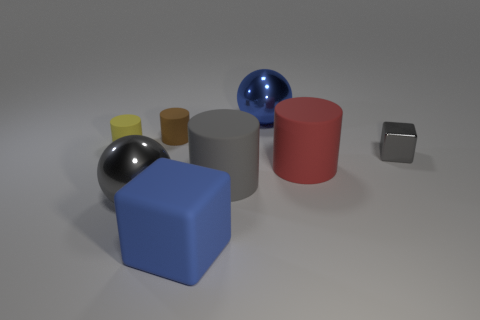Subtract all gray cylinders. How many cylinders are left? 3 Add 1 big gray things. How many objects exist? 9 Subtract all gray balls. How many balls are left? 1 Subtract all spheres. How many objects are left? 6 Subtract all red cylinders. Subtract all red cubes. How many cylinders are left? 3 Subtract all blue cubes. How many green cylinders are left? 0 Subtract all small shiny objects. Subtract all metal things. How many objects are left? 4 Add 8 big gray shiny balls. How many big gray shiny balls are left? 9 Add 7 yellow rubber things. How many yellow rubber things exist? 8 Subtract 0 red spheres. How many objects are left? 8 